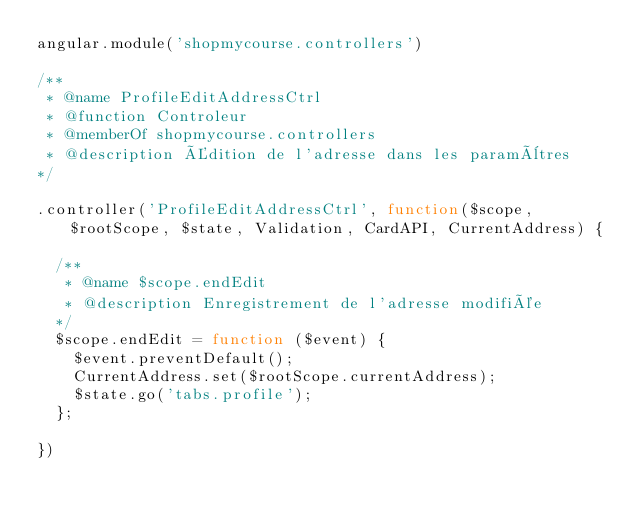<code> <loc_0><loc_0><loc_500><loc_500><_JavaScript_>angular.module('shopmycourse.controllers')

/**
 * @name ProfileEditAddressCtrl
 * @function Controleur
 * @memberOf shopmycourse.controllers
 * @description Édition de l'adresse dans les paramètres
*/

.controller('ProfileEditAddressCtrl', function($scope, $rootScope, $state, Validation, CardAPI, CurrentAddress) {

  /**
   * @name $scope.endEdit
   * @description Enregistrement de l'adresse modifiée
  */
  $scope.endEdit = function ($event) {
    $event.preventDefault();
    CurrentAddress.set($rootScope.currentAddress);
    $state.go('tabs.profile');
  };

})
</code> 